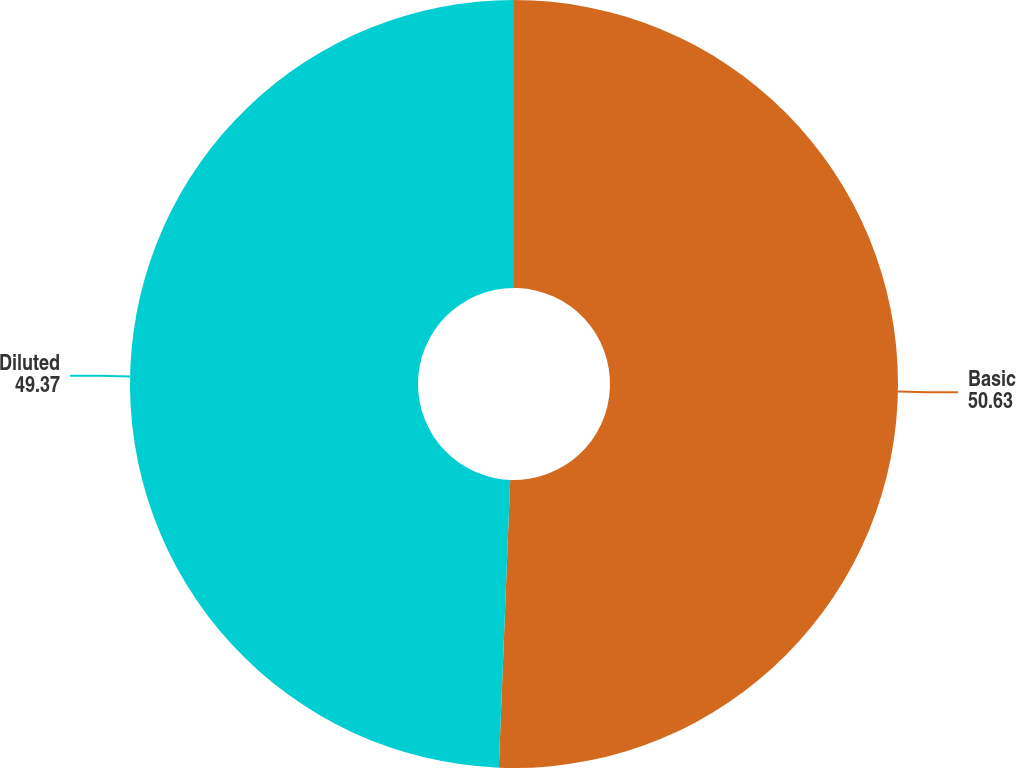<chart> <loc_0><loc_0><loc_500><loc_500><pie_chart><fcel>Basic<fcel>Diluted<nl><fcel>50.63%<fcel>49.37%<nl></chart> 